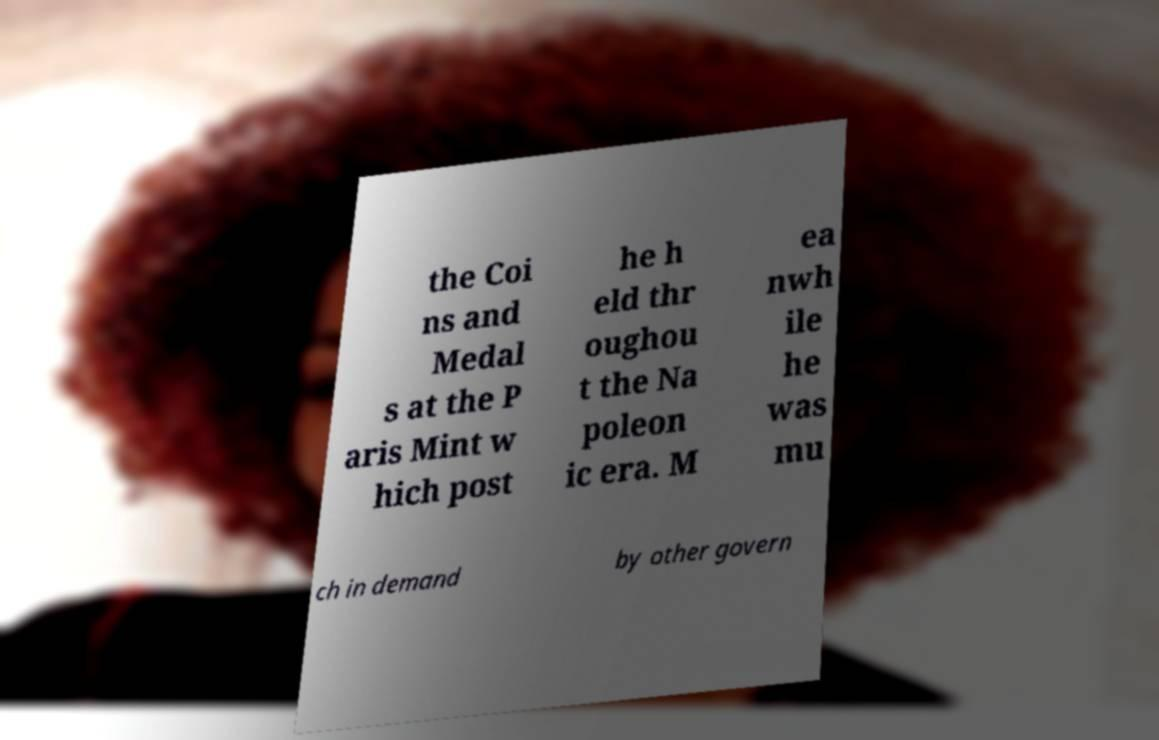Could you assist in decoding the text presented in this image and type it out clearly? the Coi ns and Medal s at the P aris Mint w hich post he h eld thr oughou t the Na poleon ic era. M ea nwh ile he was mu ch in demand by other govern 